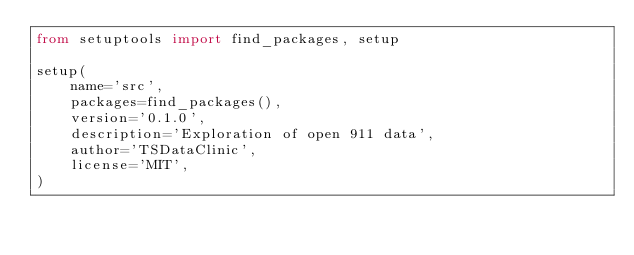<code> <loc_0><loc_0><loc_500><loc_500><_Python_>from setuptools import find_packages, setup

setup(
    name='src',
    packages=find_packages(),
    version='0.1.0',
    description='Exploration of open 911 data',
    author='TSDataClinic',
    license='MIT',
)
</code> 